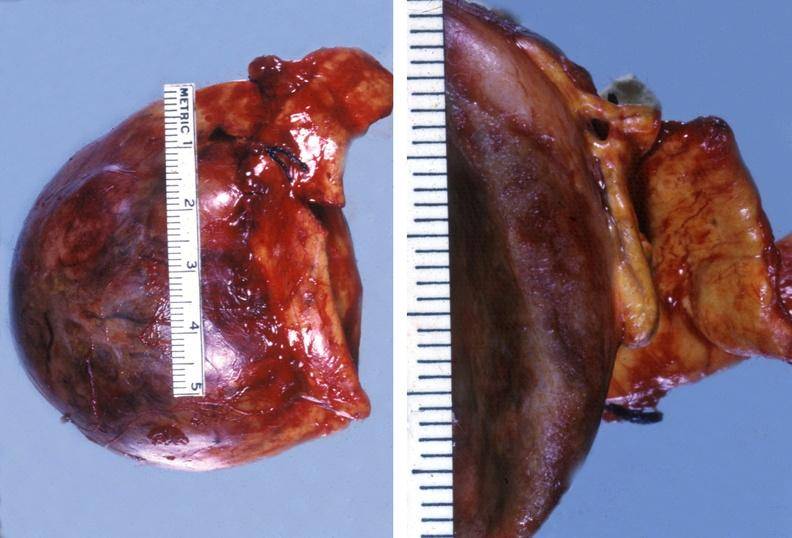does granulomata slide show adrenal phaeochromocytoma?
Answer the question using a single word or phrase. No 